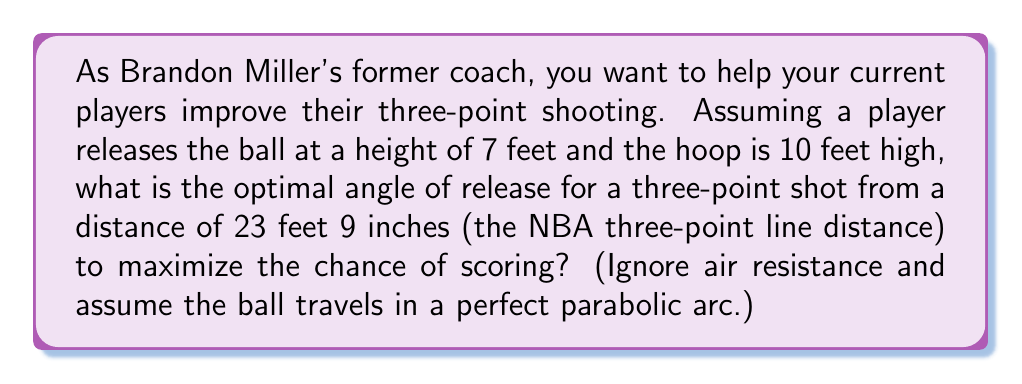Teach me how to tackle this problem. Let's approach this step-by-step:

1) First, we need to set up our coordinate system. Let's place the origin at the point of release, with the x-axis horizontal and the y-axis vertical.

2) The equation of the parabolic trajectory of the ball is:

   $$y = x \tan\theta - \frac{gx^2}{2v_0^2\cos^2\theta}$$

   where $\theta$ is the angle of release, $g$ is the acceleration due to gravity (32 ft/s²), and $v_0$ is the initial velocity.

3) We know two points on this trajectory:
   - The release point: $(0, 0)$
   - The hoop: $(23.75, 3)$ (as the hoop is 3 feet higher than the release point)

4) Substituting the hoop coordinates into our equation:

   $$3 = 23.75 \tan\theta - \frac{32(23.75)^2}{2v_0^2\cos^2\theta}$$

5) The optimal angle maximizes the chance of scoring by minimizing the initial velocity needed. We can find this by differentiating the equation with respect to $\theta$ and setting it to zero.

6) After differentiation and simplification, we get:

   $$\tan\theta = \frac{3}{23.75} \approx 0.1263$$

7) Taking the inverse tangent of both sides:

   $$\theta = \arctan(0.1263) \approx 7.19°$$

8) However, this is the angle from the horizontal to the line connecting the release point and the hoop. The optimal release angle is actually the average of this angle and 90°:

   $$\theta_{optimal} = \frac{7.19° + 90°}{2} \approx 48.60°$$
Answer: $48.60°$ 